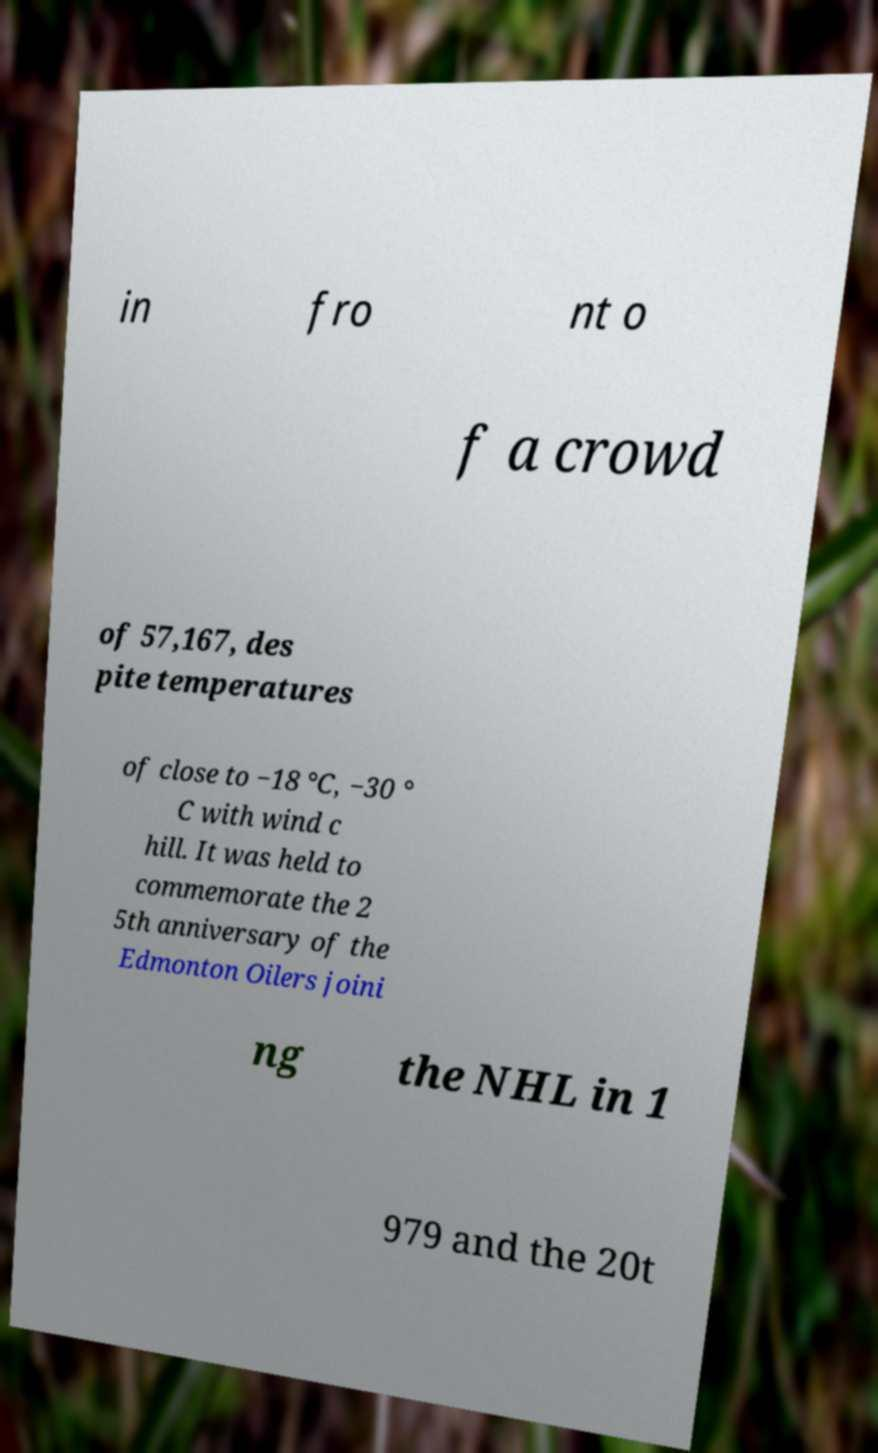Could you assist in decoding the text presented in this image and type it out clearly? in fro nt o f a crowd of 57,167, des pite temperatures of close to −18 °C, −30 ° C with wind c hill. It was held to commemorate the 2 5th anniversary of the Edmonton Oilers joini ng the NHL in 1 979 and the 20t 